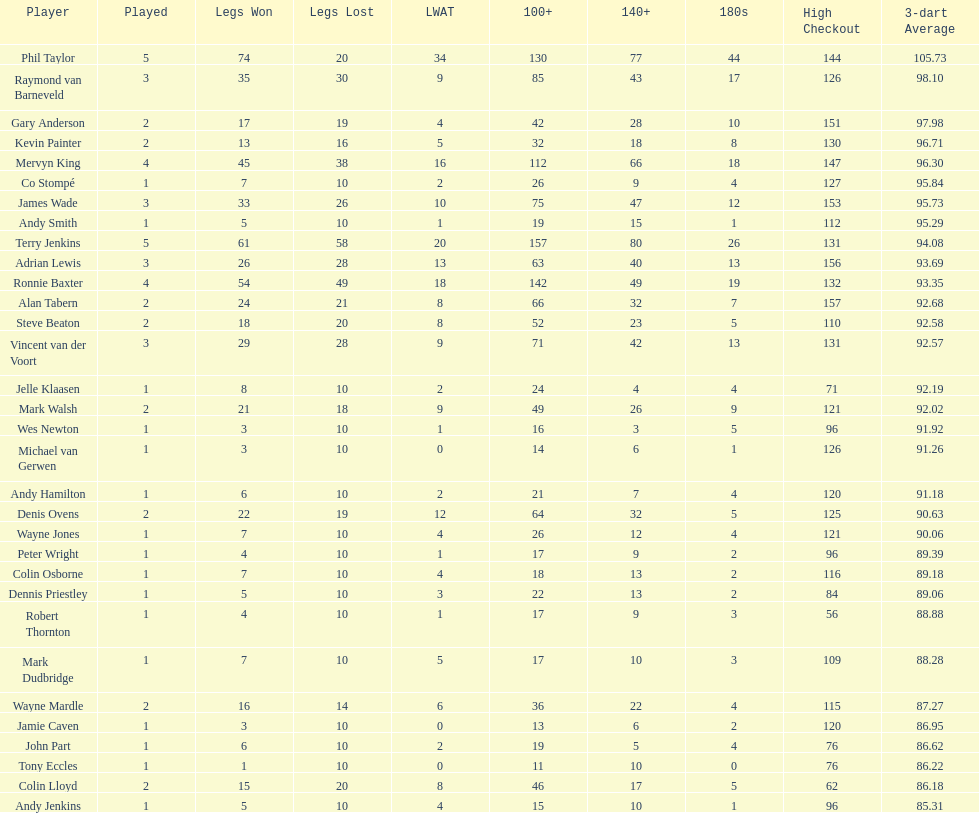Can you name all the players who have achieved a high checkout of 131? Terry Jenkins, Vincent van der Voort. 